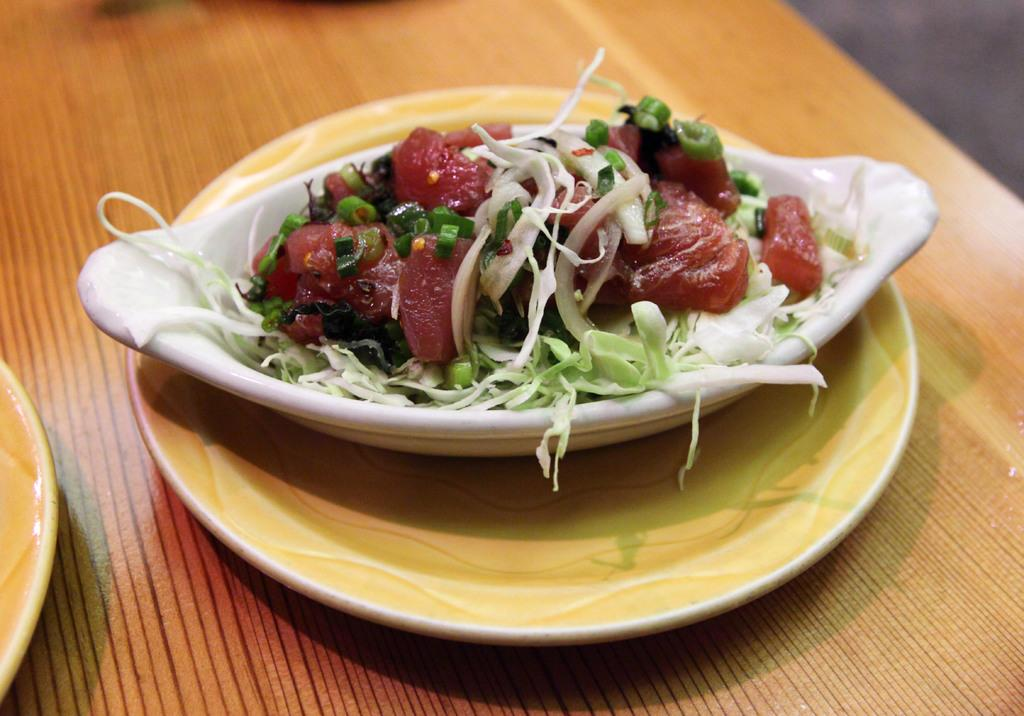What is in the bowl that is visible in the image? There is food in a bowl in the image. How is the bowl positioned in relation to other objects? The bowl is placed on a plate. Where is the plate with the bowl located? The plate with the bowl is placed on a table. Are there any other plates visible in the image? Yes, there is a plate on the left side of the table. What type of cushion is used to support the calendar on the table? There is no cushion or calendar present in the image. How many thumbs can be seen interacting with the food in the image? There are no thumbs visible in the image; it only shows a bowl of food, a plate, and another plate on the table. 